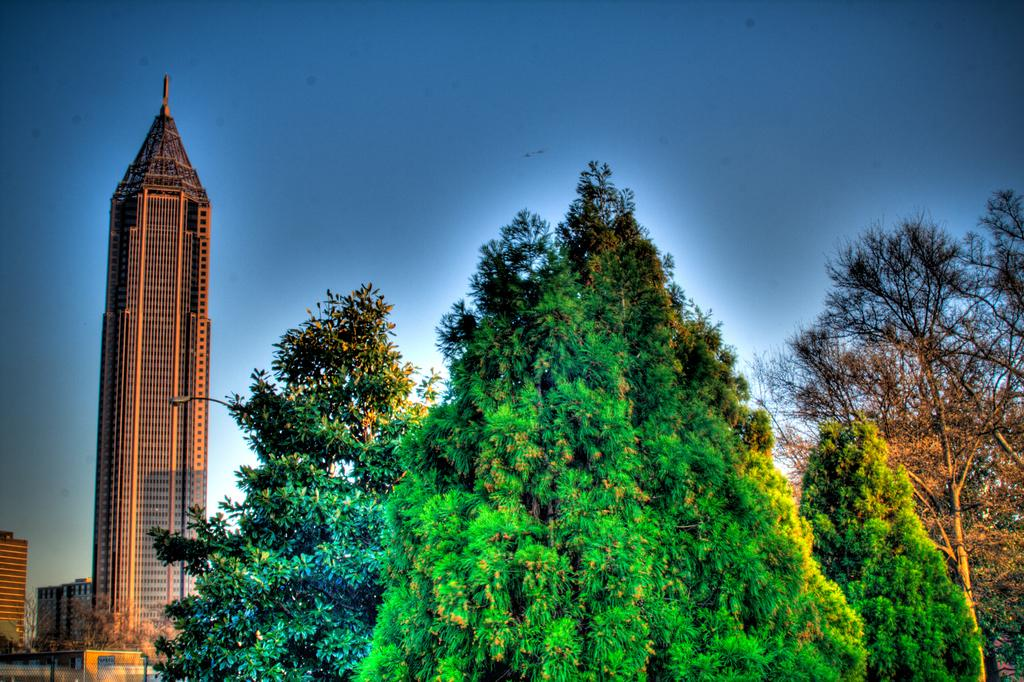What type of structures can be seen in the image? There are buildings in the image. What type of vegetation is present in the image? There are trees in the image. What type of detail can be seen on the neck of the wren in the image? There is no wren present in the image, so it is not possible to answer that question. 